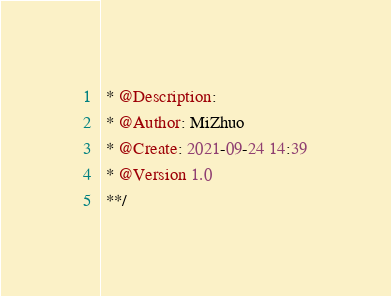<code> <loc_0><loc_0><loc_500><loc_500><_Java_> * @Description:
 * @Author: MiZhuo
 * @Create: 2021-09-24 14:39
 * @Version 1.0
 **/</code> 